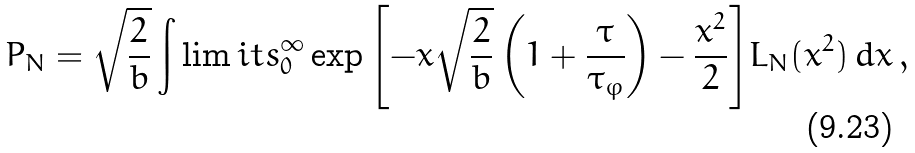Convert formula to latex. <formula><loc_0><loc_0><loc_500><loc_500>P _ { N } = \sqrt { \frac { 2 } { b } } \int \lim i t s _ { 0 } ^ { \infty } \exp { \left [ - x \sqrt { \frac { 2 } { b } } \left ( 1 + \frac { \tau } { \tau _ { \varphi } } \right ) - \frac { x ^ { 2 } } { 2 } \right ] } L _ { N } ( x ^ { 2 } ) \, d x \, ,</formula> 